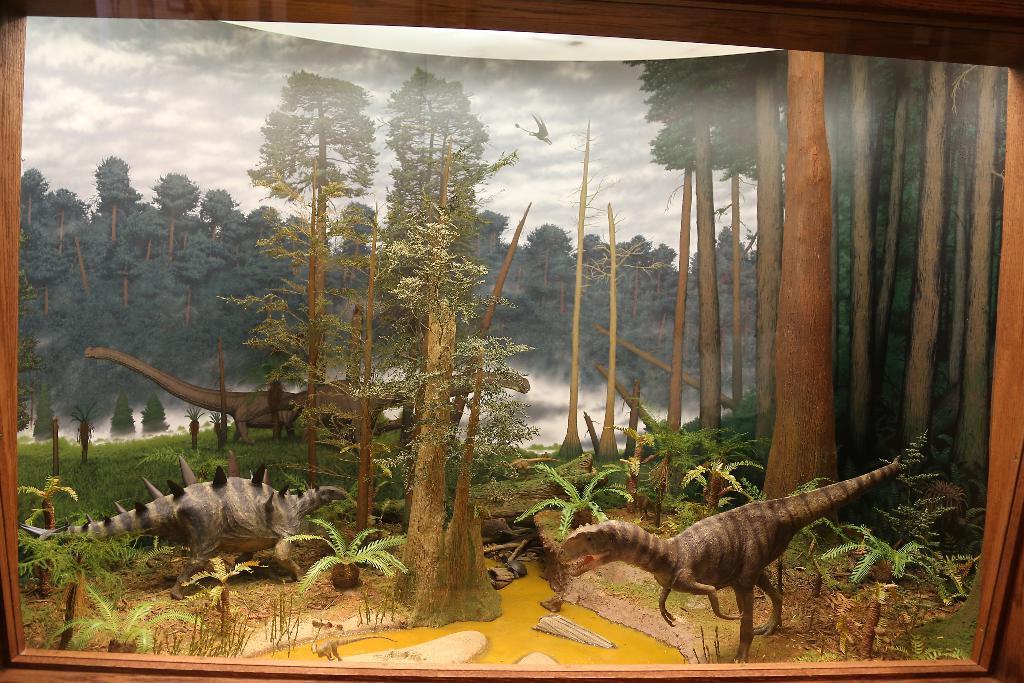How would you summarize this image in a sentence or two? In this image we can see the wooden frame. Here we can see the art of dinosaurs, plants, trees, flying dinosaur and the cloudy sky in the background. 